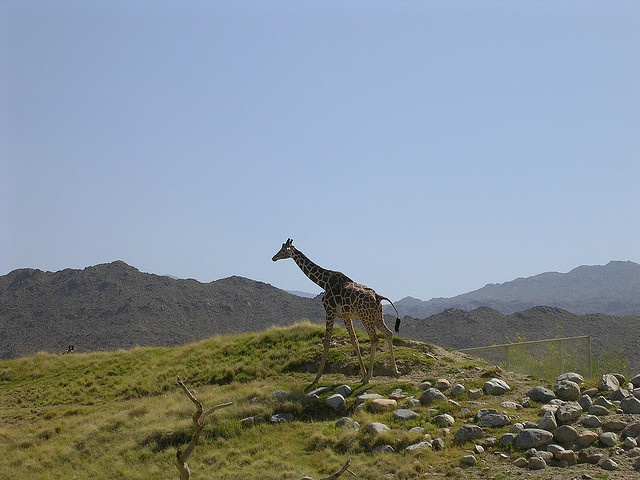Describe the objects in this image and their specific colors. I can see a giraffe in darkgray, black, darkgreen, and gray tones in this image. 